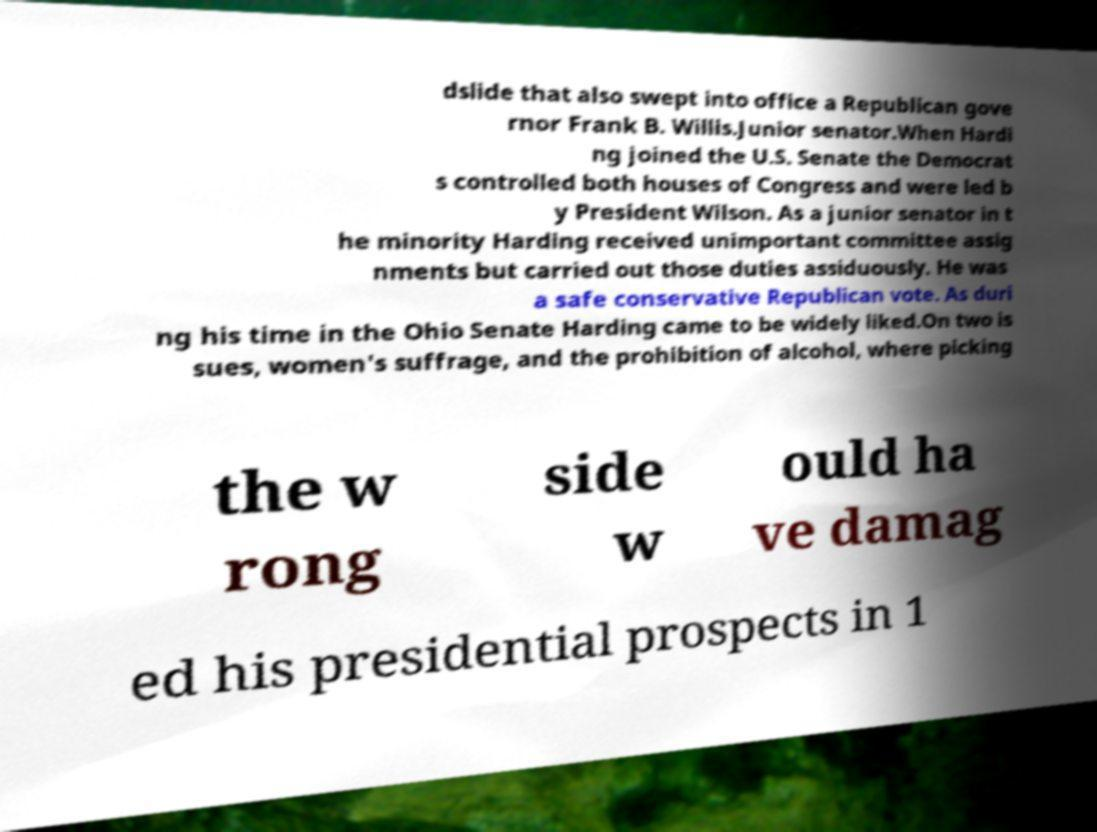What messages or text are displayed in this image? I need them in a readable, typed format. dslide that also swept into office a Republican gove rnor Frank B. Willis.Junior senator.When Hardi ng joined the U.S. Senate the Democrat s controlled both houses of Congress and were led b y President Wilson. As a junior senator in t he minority Harding received unimportant committee assig nments but carried out those duties assiduously. He was a safe conservative Republican vote. As duri ng his time in the Ohio Senate Harding came to be widely liked.On two is sues, women's suffrage, and the prohibition of alcohol, where picking the w rong side w ould ha ve damag ed his presidential prospects in 1 